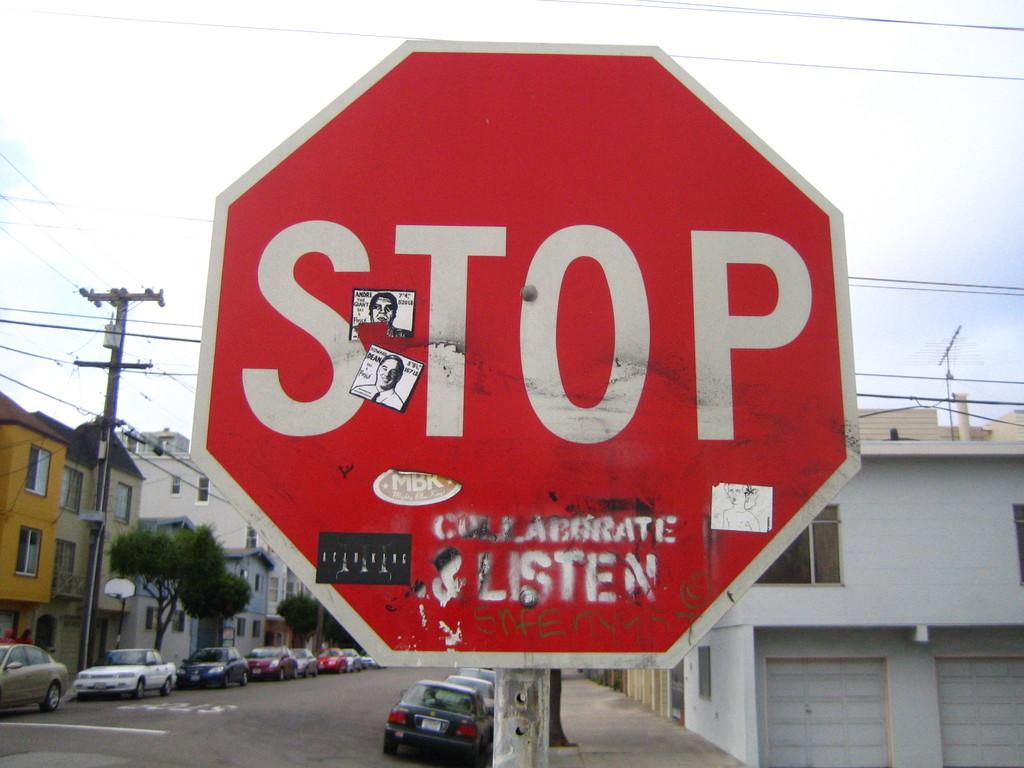<image>
Offer a succinct explanation of the picture presented. Someone has stenciled the word "listen" on the bottom of a stop sign. 